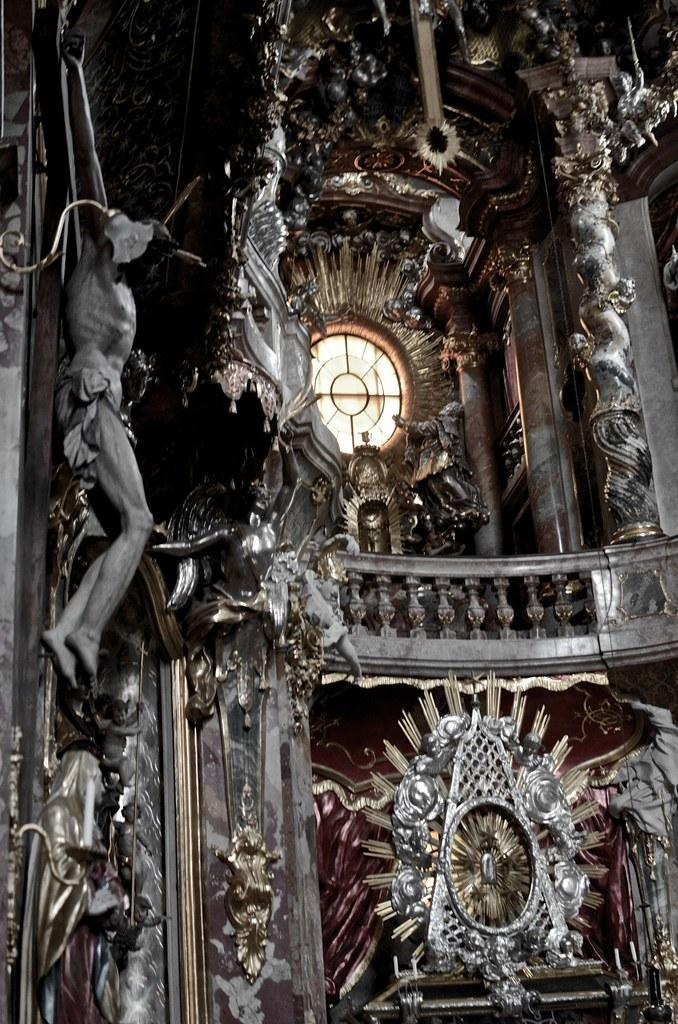What type of objects can be seen in the image? There are statues in the image. What is located in the middle of the image? There is a wall fence in the middle of the image. What can be seen in the background of the image? There is glass visible in the background of the image. What type of powder is being used to clean the statues in the image? There is no indication of any cleaning activity or powder in the image; it only shows statues, a wall fence, and glass in the background. 